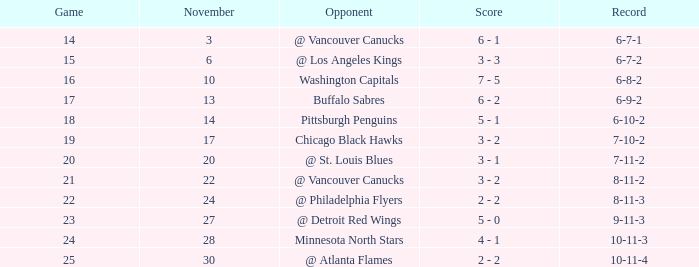What is the event scheduled for november 27? 23.0. Can you parse all the data within this table? {'header': ['Game', 'November', 'Opponent', 'Score', 'Record'], 'rows': [['14', '3', '@ Vancouver Canucks', '6 - 1', '6-7-1'], ['15', '6', '@ Los Angeles Kings', '3 - 3', '6-7-2'], ['16', '10', 'Washington Capitals', '7 - 5', '6-8-2'], ['17', '13', 'Buffalo Sabres', '6 - 2', '6-9-2'], ['18', '14', 'Pittsburgh Penguins', '5 - 1', '6-10-2'], ['19', '17', 'Chicago Black Hawks', '3 - 2', '7-10-2'], ['20', '20', '@ St. Louis Blues', '3 - 1', '7-11-2'], ['21', '22', '@ Vancouver Canucks', '3 - 2', '8-11-2'], ['22', '24', '@ Philadelphia Flyers', '2 - 2', '8-11-3'], ['23', '27', '@ Detroit Red Wings', '5 - 0', '9-11-3'], ['24', '28', 'Minnesota North Stars', '4 - 1', '10-11-3'], ['25', '30', '@ Atlanta Flames', '2 - 2', '10-11-4']]} 